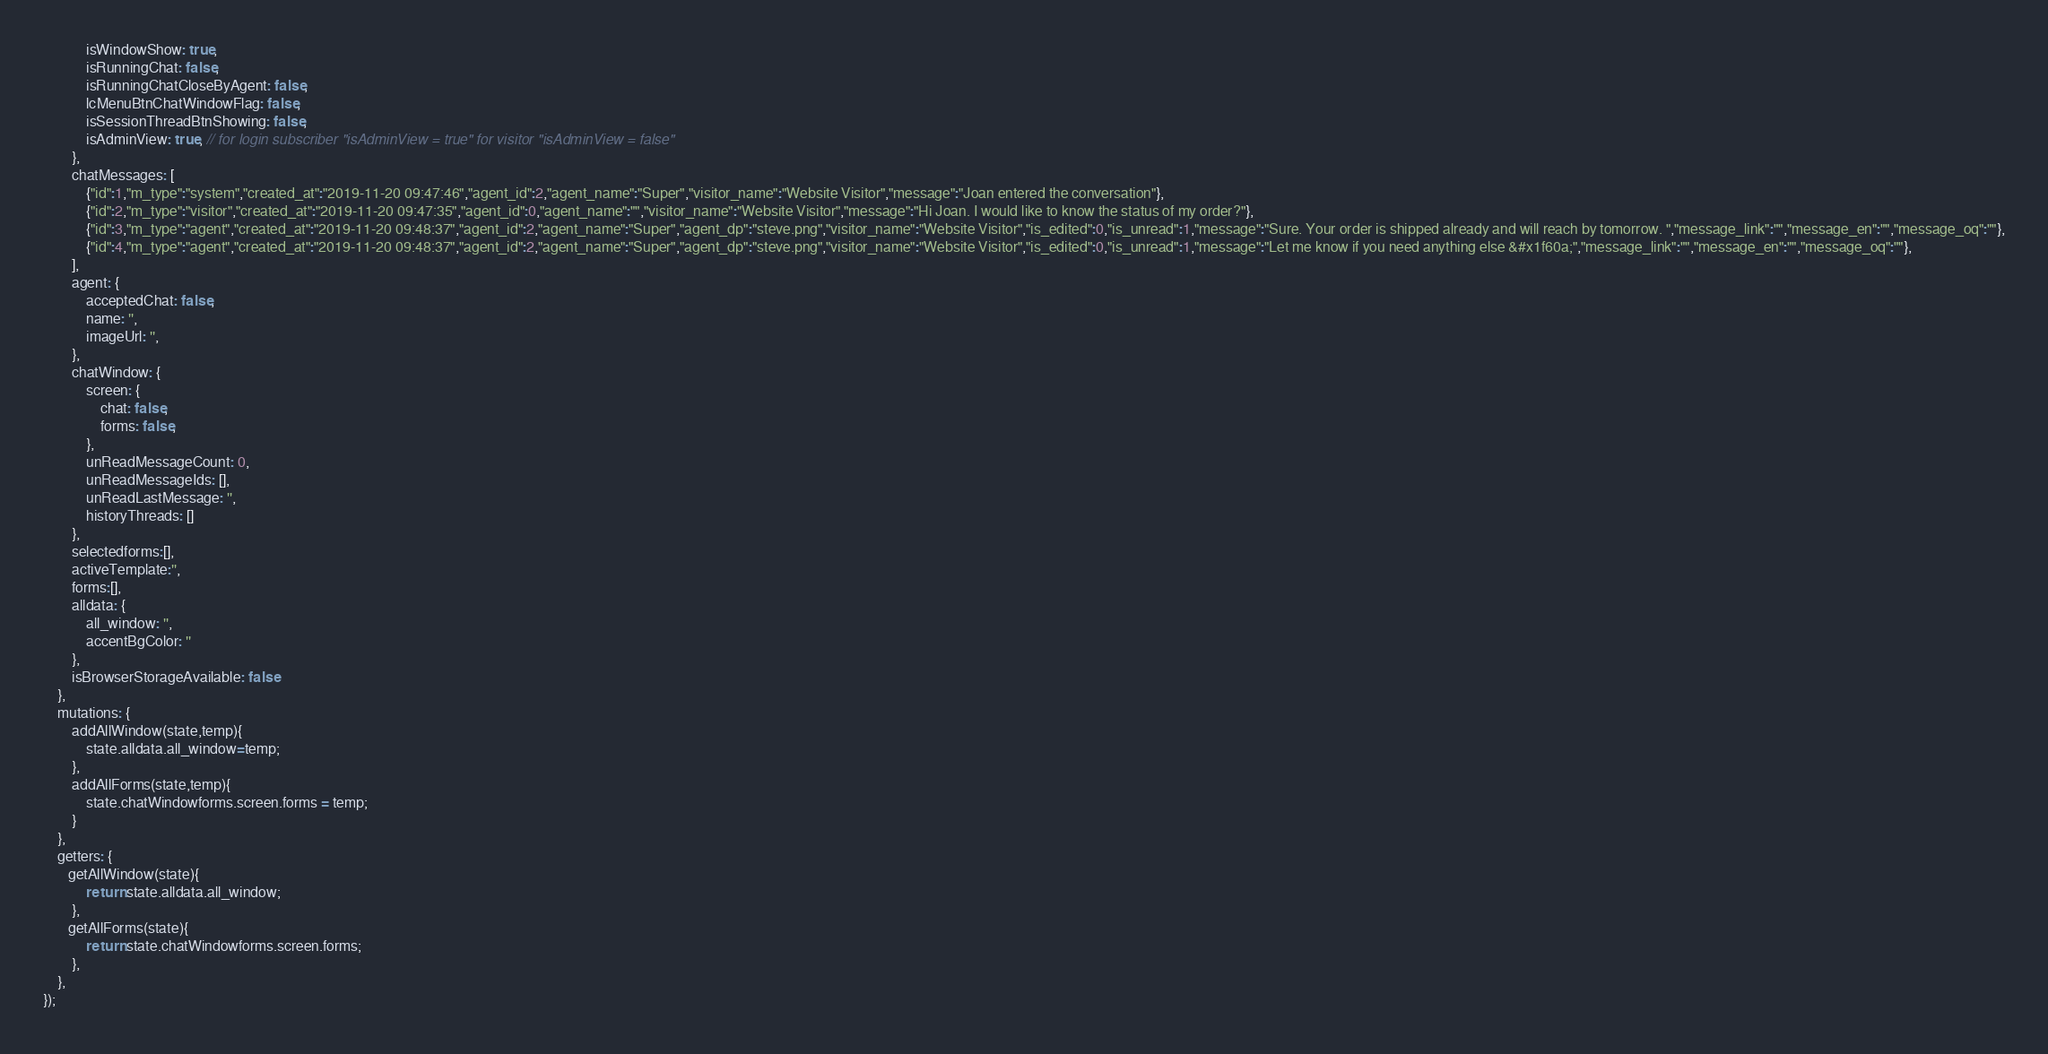Convert code to text. <code><loc_0><loc_0><loc_500><loc_500><_JavaScript_>            isWindowShow: true,
            isRunningChat: false,
            isRunningChatCloseByAgent: false,
            lcMenuBtnChatWindowFlag: false,
            isSessionThreadBtnShowing: false,            
            isAdminView: true, // for login subscriber "isAdminView = true" for visitor "isAdminView = false"
        },
        chatMessages: [
            {"id":1,"m_type":"system","created_at":"2019-11-20 09:47:46","agent_id":2,"agent_name":"Super","visitor_name":"Website Visitor","message":"Joan entered the conversation"},
            {"id":2,"m_type":"visitor","created_at":"2019-11-20 09:47:35","agent_id":0,"agent_name":"","visitor_name":"Website Visitor","message":"Hi Joan. I would like to know the status of my order?"},
            {"id":3,"m_type":"agent","created_at":"2019-11-20 09:48:37","agent_id":2,"agent_name":"Super","agent_dp":"steve.png","visitor_name":"Website Visitor","is_edited":0,"is_unread":1,"message":"Sure. Your order is shipped already and will reach by tomorrow. ","message_link":"","message_en":"","message_oq":""},
            {"id":4,"m_type":"agent","created_at":"2019-11-20 09:48:37","agent_id":2,"agent_name":"Super","agent_dp":"steve.png","visitor_name":"Website Visitor","is_edited":0,"is_unread":1,"message":"Let me know if you need anything else &#x1f60a;","message_link":"","message_en":"","message_oq":""},
        ],
        agent: {
            acceptedChat: false,
            name: '',
            imageUrl: '',
        },
        chatWindow: {
            screen: {
                chat: false,
                forms: false,
            },
            unReadMessageCount: 0,
            unReadMessageIds: [],
            unReadLastMessage: '',
            historyThreads: []
        },
        selectedforms:[],
        activeTemplate:'',
        forms:[],
        alldata: {
            all_window: '',
            accentBgColor: ''
        },
        isBrowserStorageAvailable: false
    },
    mutations: {
        addAllWindow(state,temp){
            state.alldata.all_window=temp;
        },
        addAllForms(state,temp){
            state.chatWindowforms.screen.forms = temp;
        }
    },
    getters: {
       getAllWindow(state){
            return state.alldata.all_window;
        }, 
       getAllForms(state){
            return state.chatWindowforms.screen.forms;
        }, 
    },
});


</code> 